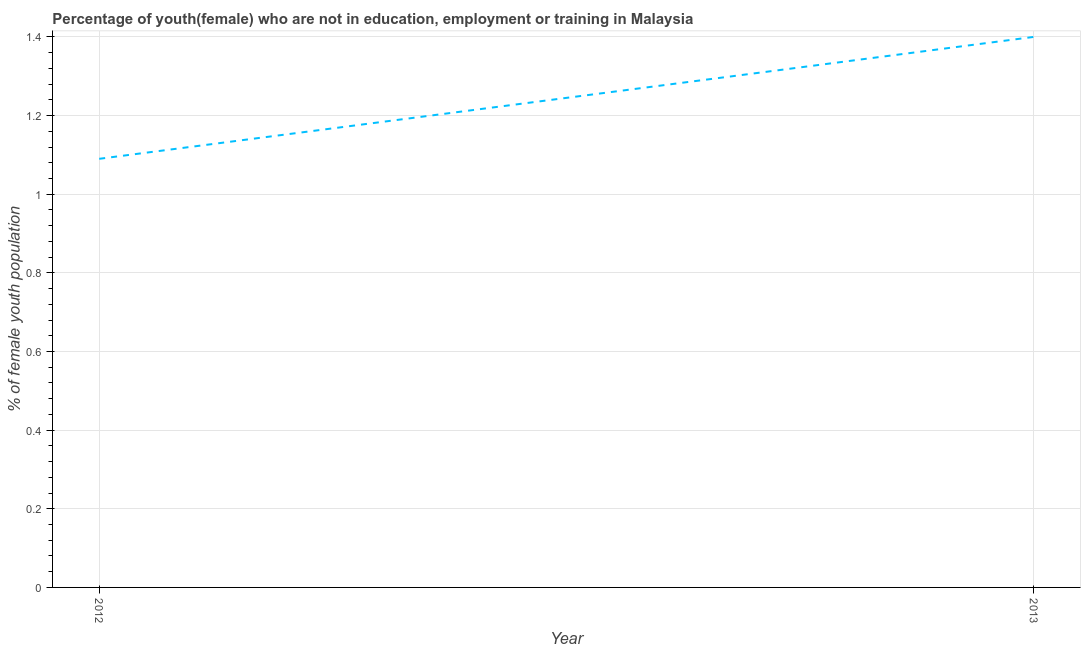What is the unemployed female youth population in 2012?
Give a very brief answer. 1.09. Across all years, what is the maximum unemployed female youth population?
Provide a short and direct response. 1.4. Across all years, what is the minimum unemployed female youth population?
Your answer should be very brief. 1.09. In which year was the unemployed female youth population minimum?
Provide a succinct answer. 2012. What is the sum of the unemployed female youth population?
Keep it short and to the point. 2.49. What is the difference between the unemployed female youth population in 2012 and 2013?
Make the answer very short. -0.31. What is the average unemployed female youth population per year?
Your answer should be very brief. 1.25. What is the median unemployed female youth population?
Keep it short and to the point. 1.25. In how many years, is the unemployed female youth population greater than 0.32 %?
Make the answer very short. 2. What is the ratio of the unemployed female youth population in 2012 to that in 2013?
Ensure brevity in your answer.  0.78. In how many years, is the unemployed female youth population greater than the average unemployed female youth population taken over all years?
Your response must be concise. 1. Does the unemployed female youth population monotonically increase over the years?
Your response must be concise. Yes. How many lines are there?
Make the answer very short. 1. Does the graph contain any zero values?
Your answer should be very brief. No. Does the graph contain grids?
Make the answer very short. Yes. What is the title of the graph?
Offer a terse response. Percentage of youth(female) who are not in education, employment or training in Malaysia. What is the label or title of the X-axis?
Make the answer very short. Year. What is the label or title of the Y-axis?
Offer a very short reply. % of female youth population. What is the % of female youth population in 2012?
Keep it short and to the point. 1.09. What is the % of female youth population in 2013?
Keep it short and to the point. 1.4. What is the difference between the % of female youth population in 2012 and 2013?
Offer a terse response. -0.31. What is the ratio of the % of female youth population in 2012 to that in 2013?
Ensure brevity in your answer.  0.78. 